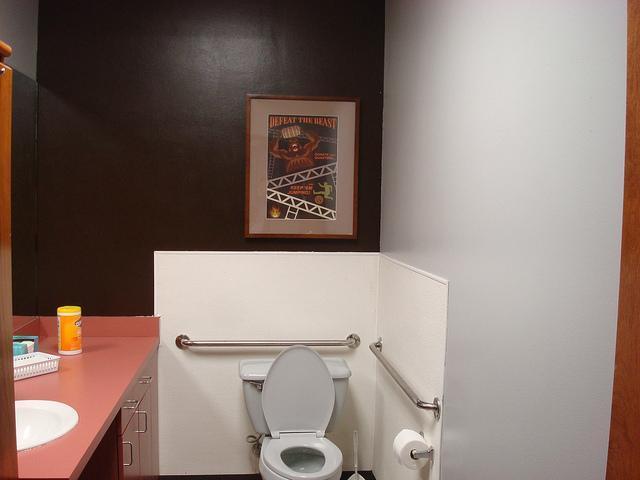How many rolls of toilet paper are visible?
Give a very brief answer. 1. 